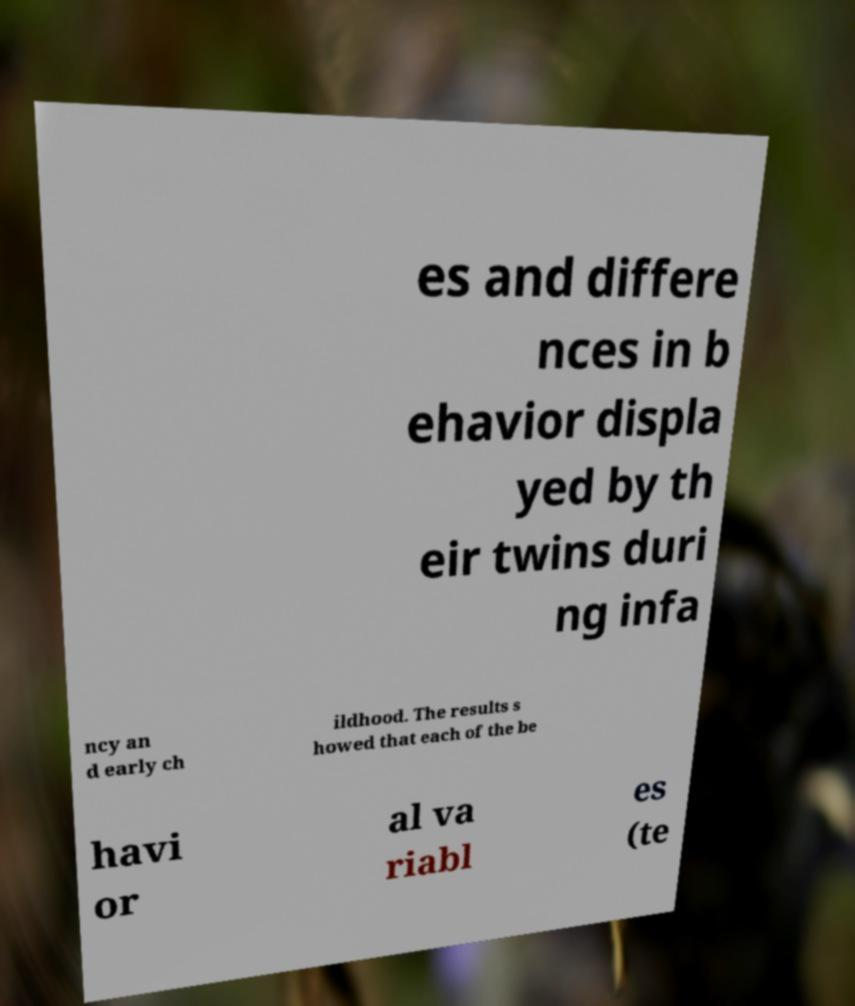Can you accurately transcribe the text from the provided image for me? es and differe nces in b ehavior displa yed by th eir twins duri ng infa ncy an d early ch ildhood. The results s howed that each of the be havi or al va riabl es (te 